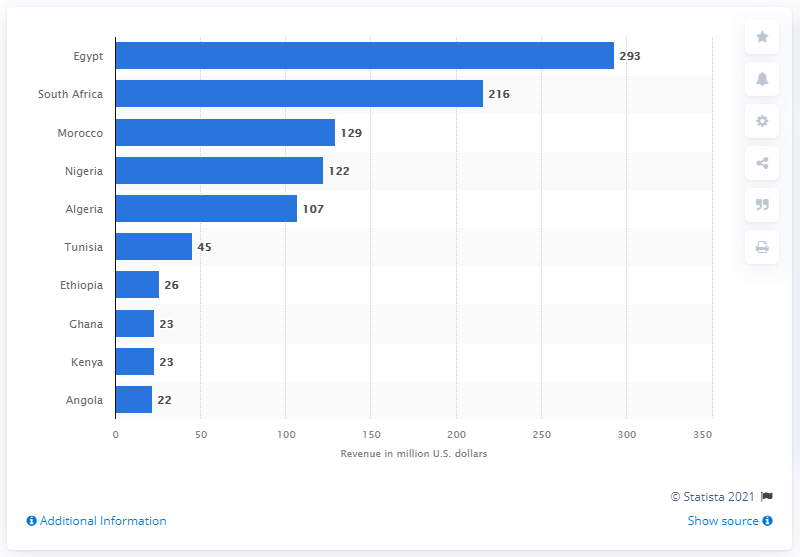Give some essential details in this illustration. In 2018, Egypt generated a total of approximately 293 million U.S. dollars in revenue.

번역결과  
2018년, EGYPT은 약 2930000000 美륨의 수익을 얻었습니다. According to a 2018 report, the top gaming market in Africa was Egypt. According to data from 2018, Morocco ranked third among African countries in terms of overall performance. 